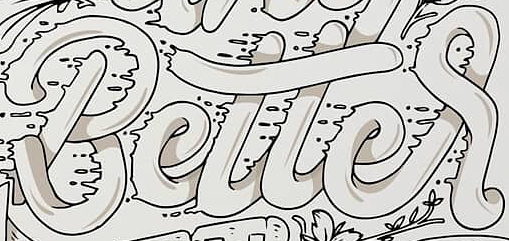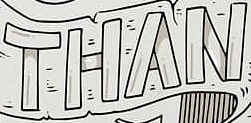Read the text from these images in sequence, separated by a semicolon. Better; THAN 